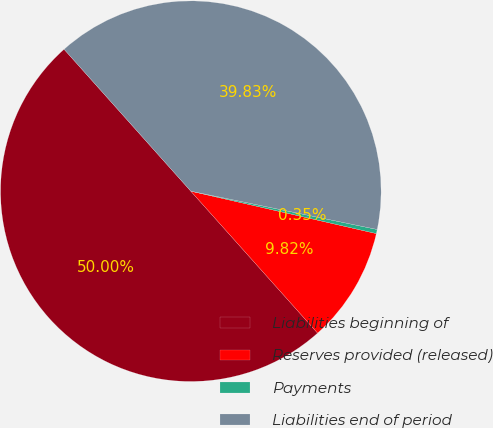Convert chart to OTSL. <chart><loc_0><loc_0><loc_500><loc_500><pie_chart><fcel>Liabilities beginning of<fcel>Reserves provided (released)<fcel>Payments<fcel>Liabilities end of period<nl><fcel>50.0%<fcel>9.82%<fcel>0.35%<fcel>39.83%<nl></chart> 